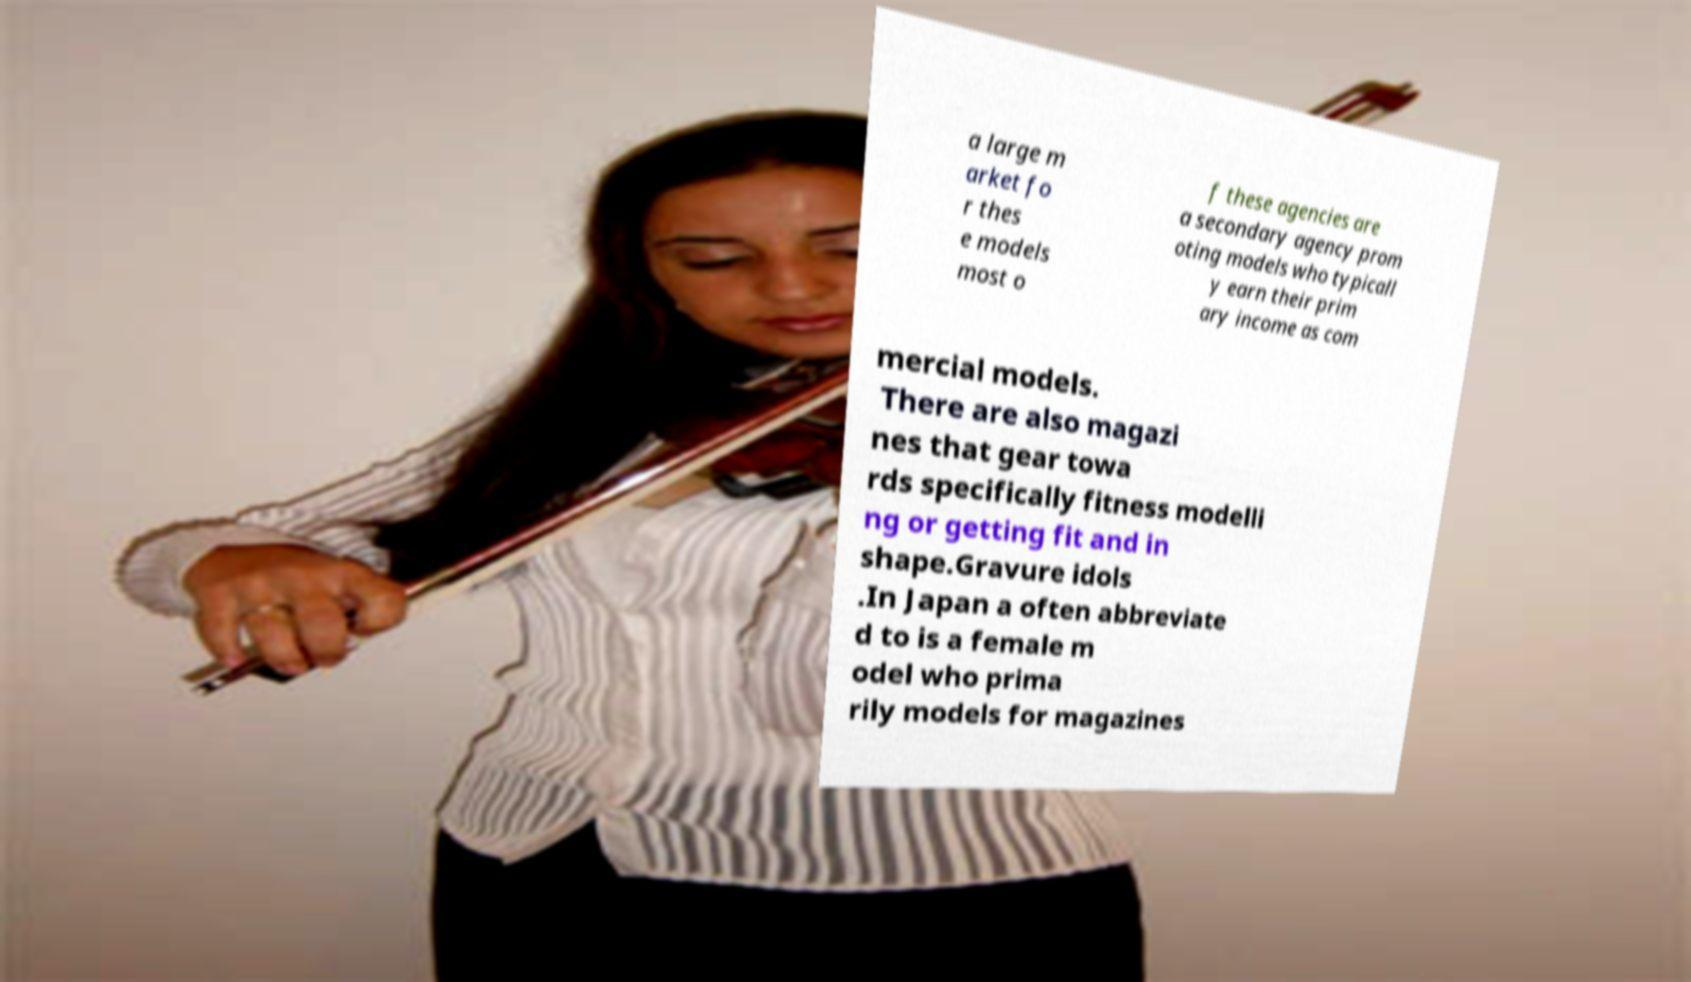Can you accurately transcribe the text from the provided image for me? a large m arket fo r thes e models most o f these agencies are a secondary agency prom oting models who typicall y earn their prim ary income as com mercial models. There are also magazi nes that gear towa rds specifically fitness modelli ng or getting fit and in shape.Gravure idols .In Japan a often abbreviate d to is a female m odel who prima rily models for magazines 